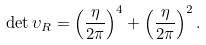<formula> <loc_0><loc_0><loc_500><loc_500>\det \upsilon _ { R } = \left ( \frac { \eta } { 2 \pi } \right ) ^ { 4 } + \left ( \frac { \eta } { 2 \pi } \right ) ^ { 2 } .</formula> 